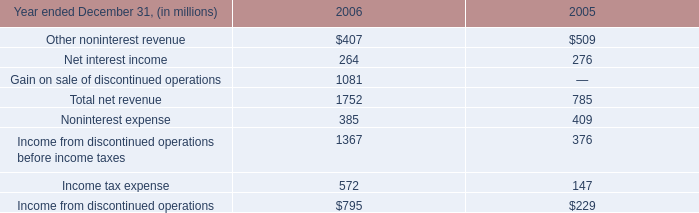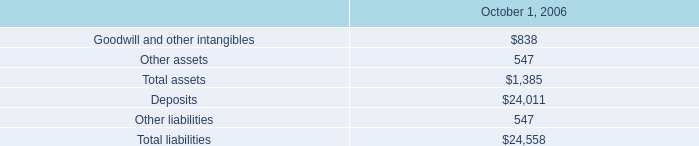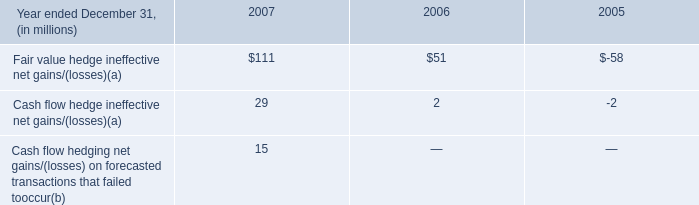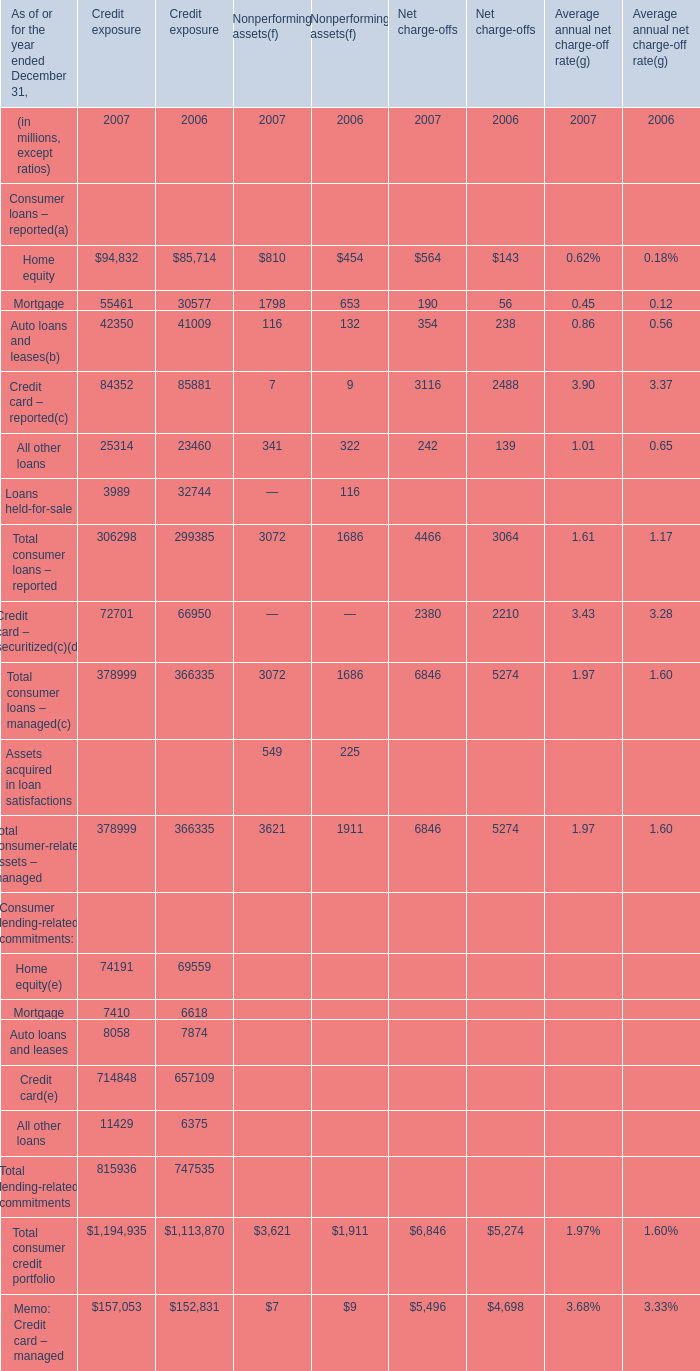What is the total amount of All other loans of Credit exposure 2007, Income from discontinued operations before income taxes of 2006, and Credit card – reported of Credit exposure 2006 ? 
Computations: ((25314.0 + 1367.0) + 85881.0)
Answer: 112562.0. 